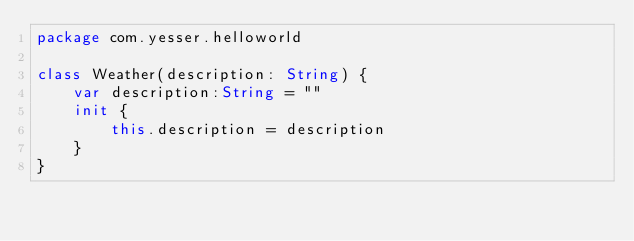<code> <loc_0><loc_0><loc_500><loc_500><_Kotlin_>package com.yesser.helloworld

class Weather(description: String) {
    var description:String = ""
    init {
        this.description = description
    }
}</code> 